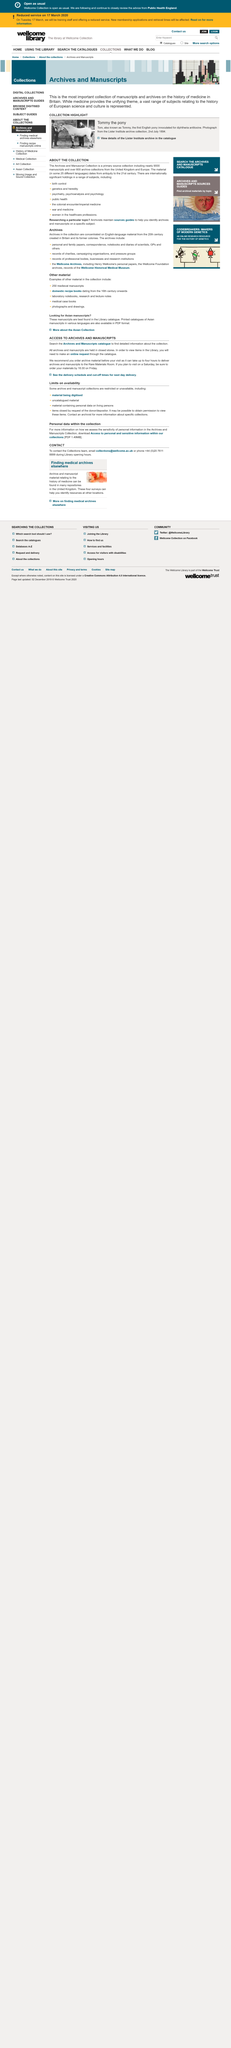Specify some key components in this picture. Tommy the pony is a well-known English pony that has been injected with diphtheria antitoxin. This photograph is from the archive collection of The Lister Institute. The Archives and Manuscripts catalogue will provide access to archives and manuscripts. Archival and manuscript materials are kept in secure storage facilities and delivered to the Rare Materials Room. You can call the library during its opening hours. 